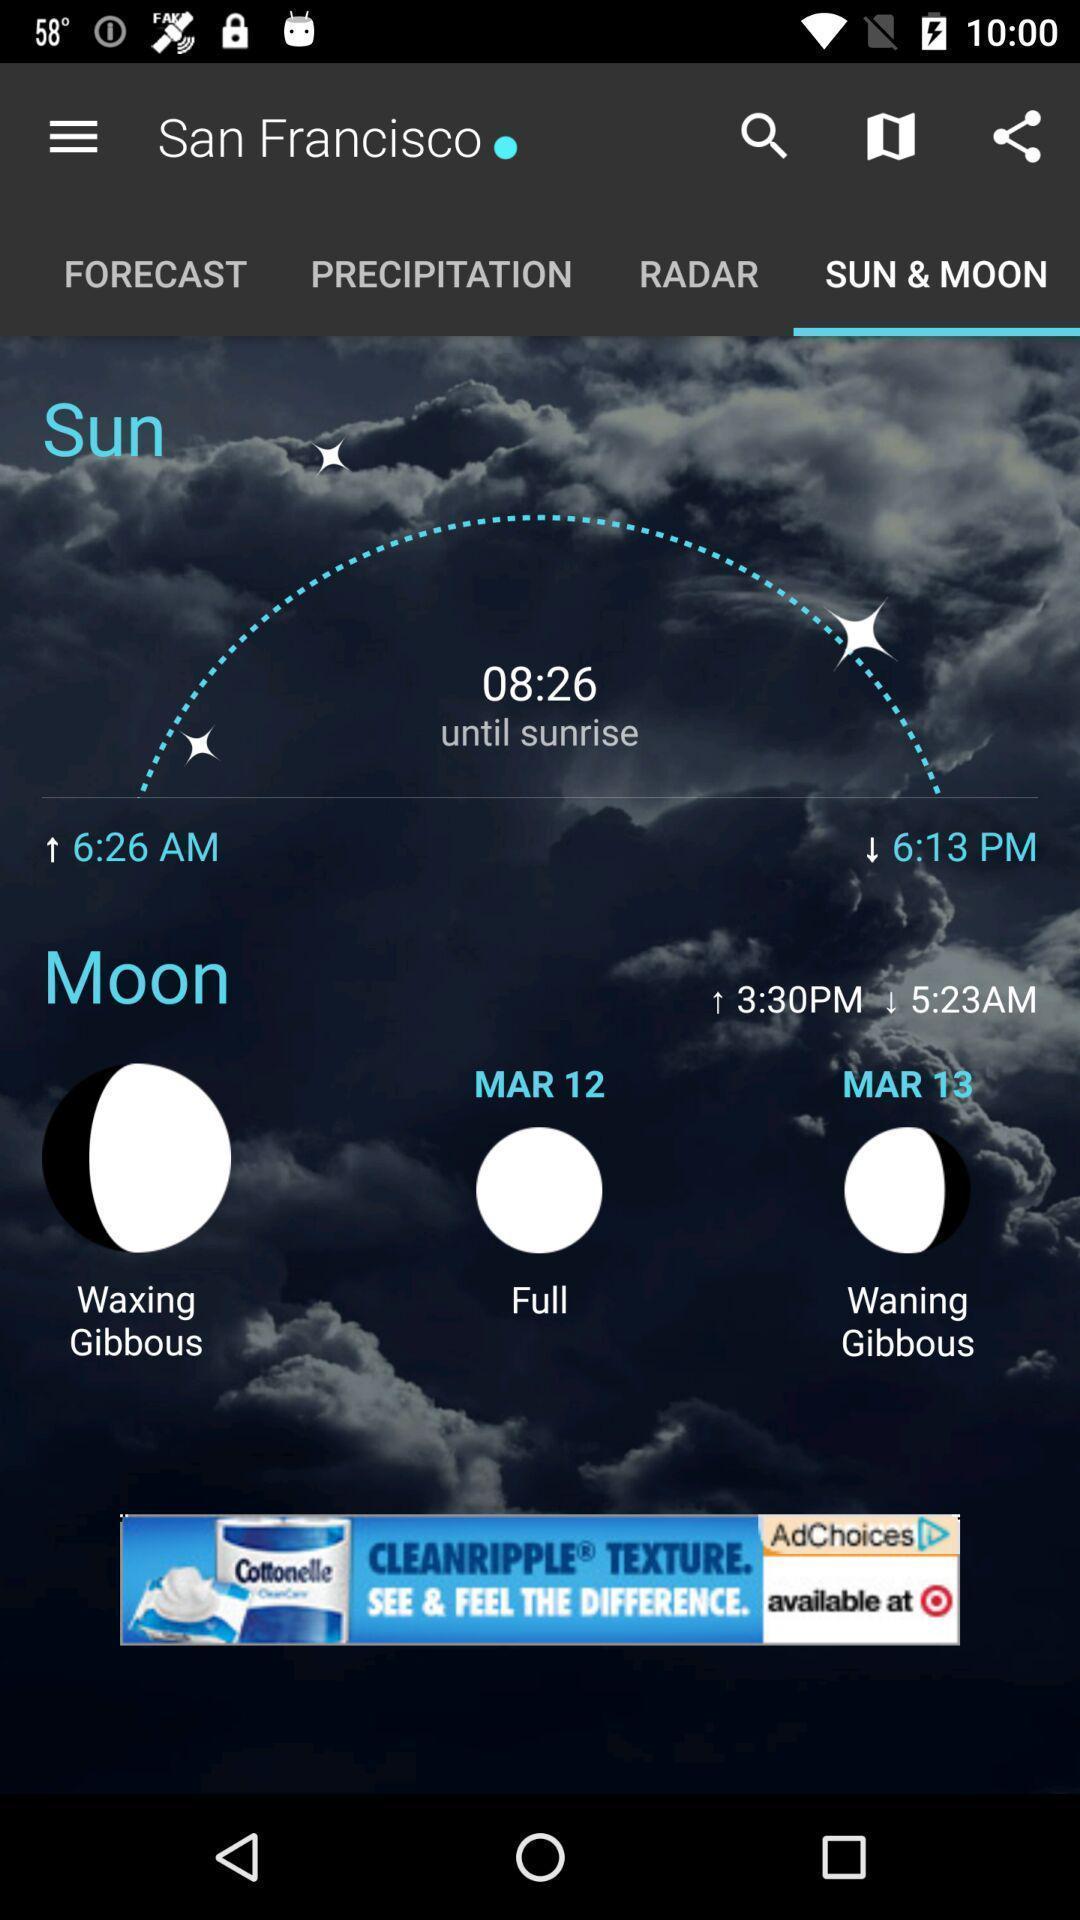Describe the content in this image. Screen displaying multiple options in a weather application. 